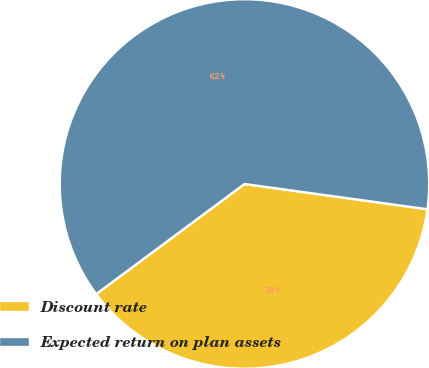<chart> <loc_0><loc_0><loc_500><loc_500><pie_chart><fcel>Discount rate<fcel>Expected return on plan assets<nl><fcel>37.65%<fcel>62.35%<nl></chart> 